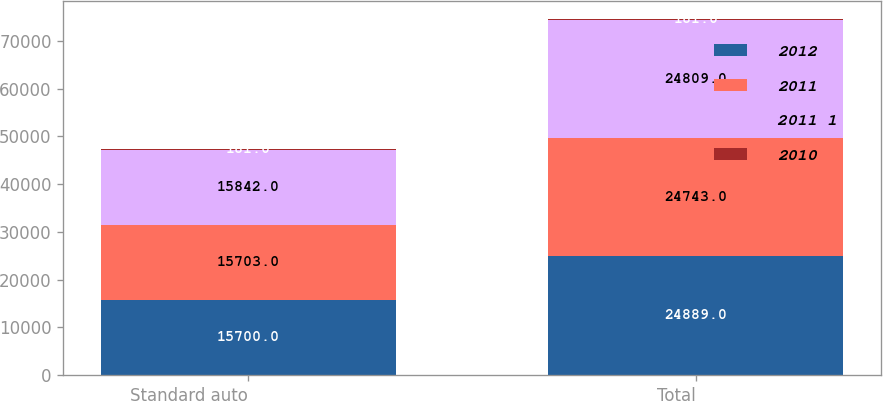Convert chart to OTSL. <chart><loc_0><loc_0><loc_500><loc_500><stacked_bar_chart><ecel><fcel>Standard auto<fcel>Total<nl><fcel>2012<fcel>15700<fcel>24889<nl><fcel>2011<fcel>15703<fcel>24743<nl><fcel>2011 1<fcel>15842<fcel>24809<nl><fcel>2010<fcel>181<fcel>181<nl></chart> 